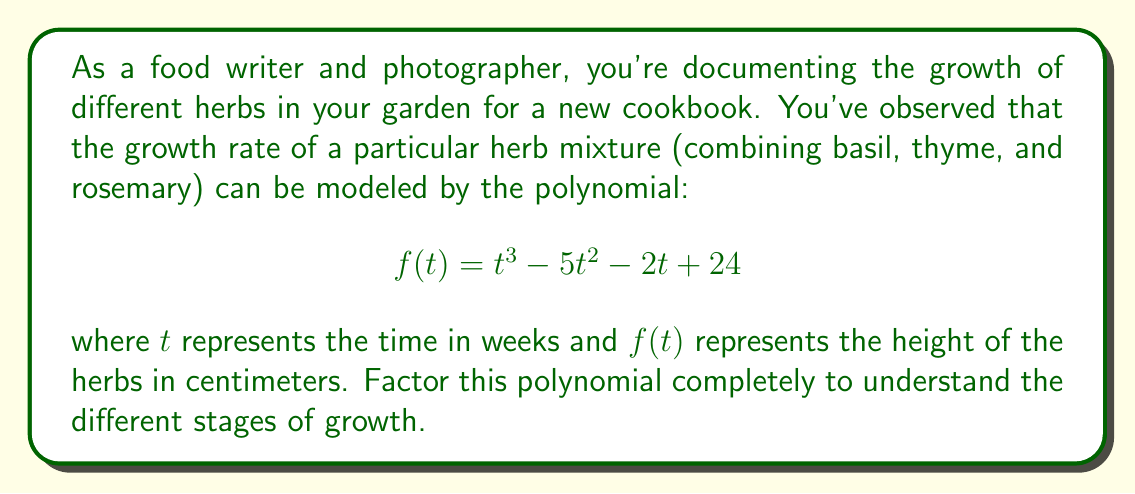Show me your answer to this math problem. To factor this polynomial, we'll follow these steps:

1) First, let's check if there are any rational roots using the rational root theorem. The possible rational roots are the factors of the constant term: $\pm 1, \pm 2, \pm 3, \pm 4, \pm 6, \pm 8, \pm 12, \pm 24$.

2) Testing these values, we find that $t = 4$ is a root of the polynomial. So $(t - 4)$ is a factor.

3) We can use polynomial long division to divide $f(t)$ by $(t - 4)$:

   $$\frac{t^3 - 5t^2 - 2t + 24}{t - 4} = t^2 + t - 6$$

4) So now we have: $f(t) = (t - 4)(t^2 + t - 6)$

5) The quadratic factor $t^2 + t - 6$ can be factored further:
   
   $$t^2 + t - 6 = (t + 3)(t - 2)$$

6) Therefore, the complete factorization is:

   $$f(t) = (t - 4)(t + 3)(t - 2)$$

This factorization shows that the herb mixture reaches its initial height (0 cm) at 4 weeks, -3 weeks (which isn't practically meaningful for growth), and 2 weeks. The negative root (-3) and the root at 2 weeks represent theoretical points where the growth rate changes direction, which could correspond to different stages in the herbs' growth cycle.
Answer: $$f(t) = (t - 4)(t + 3)(t - 2)$$ 